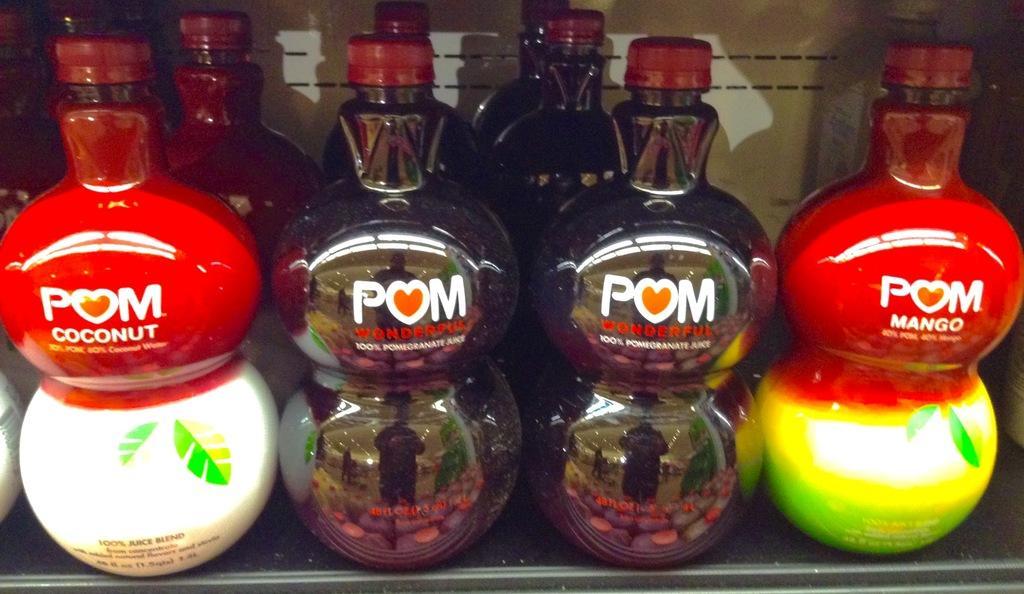Describe this image in one or two sentences. We can see group of bottle with red color caps on the rack. 